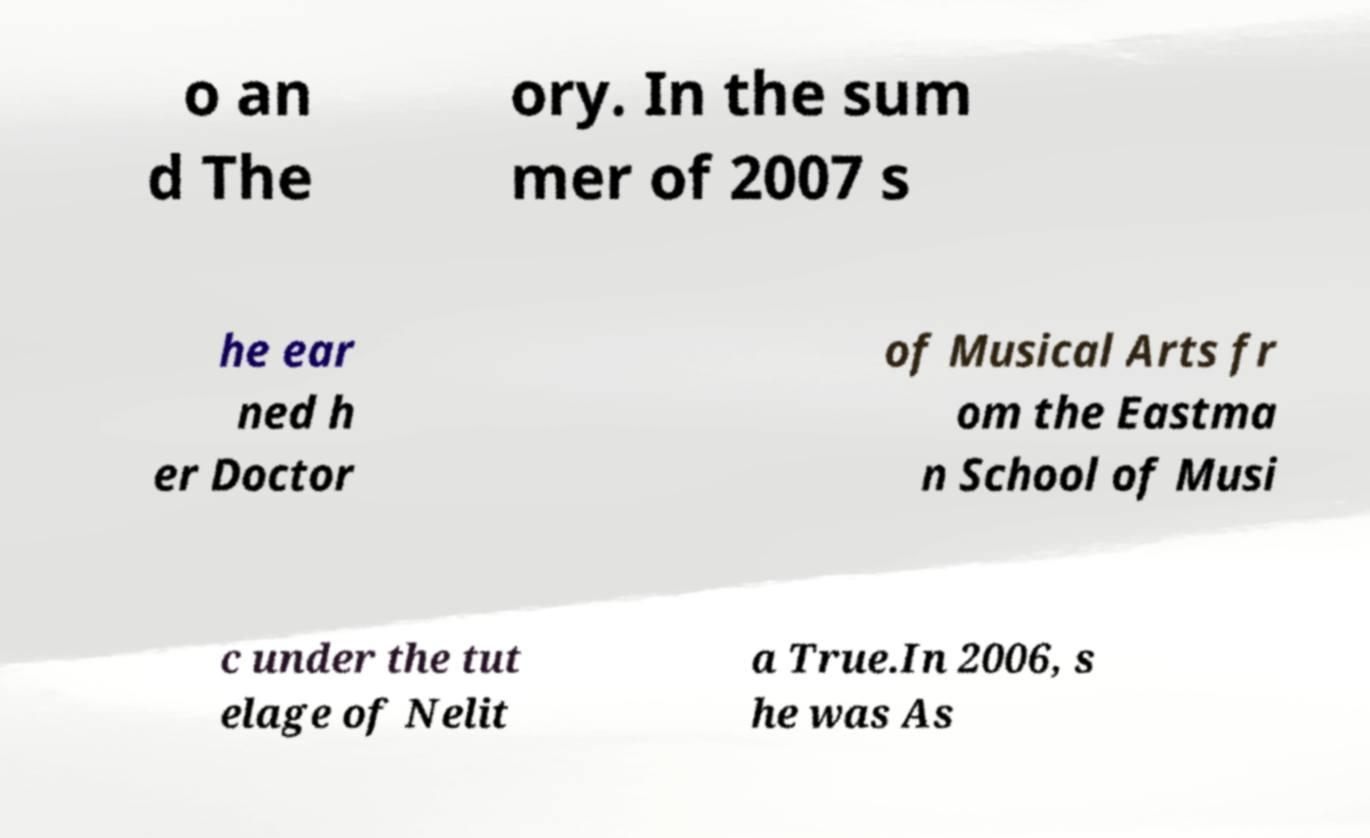Please identify and transcribe the text found in this image. o an d The ory. In the sum mer of 2007 s he ear ned h er Doctor of Musical Arts fr om the Eastma n School of Musi c under the tut elage of Nelit a True.In 2006, s he was As 